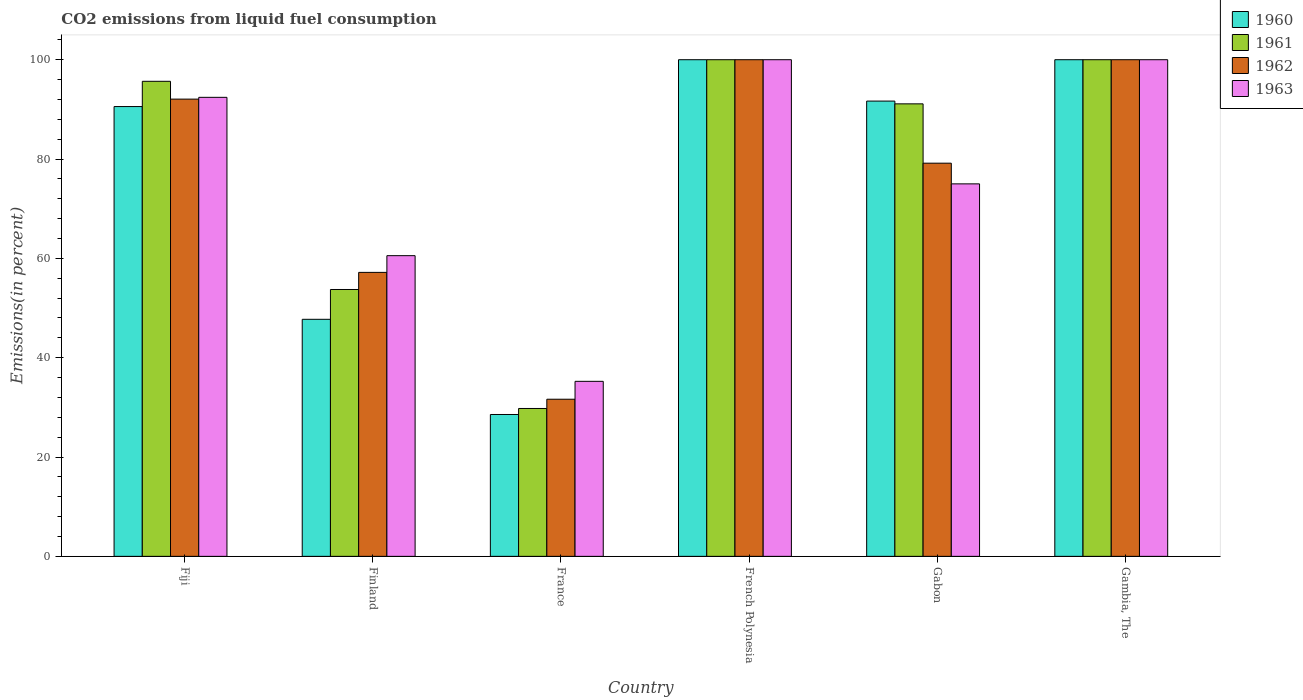How many different coloured bars are there?
Offer a terse response. 4. Are the number of bars per tick equal to the number of legend labels?
Ensure brevity in your answer.  Yes. Are the number of bars on each tick of the X-axis equal?
Provide a succinct answer. Yes. How many bars are there on the 3rd tick from the left?
Provide a short and direct response. 4. How many bars are there on the 4th tick from the right?
Offer a terse response. 4. Across all countries, what is the minimum total CO2 emitted in 1962?
Provide a short and direct response. 31.64. In which country was the total CO2 emitted in 1962 maximum?
Offer a very short reply. French Polynesia. What is the total total CO2 emitted in 1961 in the graph?
Offer a very short reply. 470.27. What is the difference between the total CO2 emitted in 1963 in Fiji and that in Gambia, The?
Your answer should be very brief. -7.58. What is the difference between the total CO2 emitted in 1961 in Gabon and the total CO2 emitted in 1963 in Finland?
Keep it short and to the point. 30.57. What is the average total CO2 emitted in 1961 per country?
Ensure brevity in your answer.  78.38. What is the difference between the total CO2 emitted of/in 1963 and total CO2 emitted of/in 1962 in France?
Your response must be concise. 3.6. In how many countries, is the total CO2 emitted in 1960 greater than 72 %?
Offer a terse response. 4. What is the ratio of the total CO2 emitted in 1961 in France to that in Gambia, The?
Your answer should be compact. 0.3. Is the total CO2 emitted in 1960 in France less than that in French Polynesia?
Your response must be concise. Yes. Is the difference between the total CO2 emitted in 1963 in Fiji and French Polynesia greater than the difference between the total CO2 emitted in 1962 in Fiji and French Polynesia?
Provide a short and direct response. Yes. What is the difference between the highest and the second highest total CO2 emitted in 1961?
Your answer should be very brief. 4.35. What is the difference between the highest and the lowest total CO2 emitted in 1962?
Make the answer very short. 68.36. What does the 3rd bar from the left in Finland represents?
Give a very brief answer. 1962. Is it the case that in every country, the sum of the total CO2 emitted in 1960 and total CO2 emitted in 1963 is greater than the total CO2 emitted in 1962?
Make the answer very short. Yes. How many bars are there?
Provide a succinct answer. 24. How many countries are there in the graph?
Provide a succinct answer. 6. What is the difference between two consecutive major ticks on the Y-axis?
Your answer should be very brief. 20. Are the values on the major ticks of Y-axis written in scientific E-notation?
Offer a terse response. No. Does the graph contain any zero values?
Offer a terse response. No. How many legend labels are there?
Keep it short and to the point. 4. What is the title of the graph?
Offer a terse response. CO2 emissions from liquid fuel consumption. Does "1977" appear as one of the legend labels in the graph?
Provide a succinct answer. No. What is the label or title of the X-axis?
Ensure brevity in your answer.  Country. What is the label or title of the Y-axis?
Your answer should be very brief. Emissions(in percent). What is the Emissions(in percent) in 1960 in Fiji?
Your response must be concise. 90.57. What is the Emissions(in percent) in 1961 in Fiji?
Ensure brevity in your answer.  95.65. What is the Emissions(in percent) of 1962 in Fiji?
Provide a short and direct response. 92.06. What is the Emissions(in percent) of 1963 in Fiji?
Your answer should be compact. 92.42. What is the Emissions(in percent) of 1960 in Finland?
Ensure brevity in your answer.  47.73. What is the Emissions(in percent) of 1961 in Finland?
Your answer should be compact. 53.73. What is the Emissions(in percent) of 1962 in Finland?
Provide a short and direct response. 57.18. What is the Emissions(in percent) in 1963 in Finland?
Give a very brief answer. 60.54. What is the Emissions(in percent) in 1960 in France?
Provide a succinct answer. 28.56. What is the Emissions(in percent) of 1961 in France?
Your response must be concise. 29.77. What is the Emissions(in percent) of 1962 in France?
Your response must be concise. 31.64. What is the Emissions(in percent) of 1963 in France?
Your answer should be very brief. 35.24. What is the Emissions(in percent) of 1961 in French Polynesia?
Offer a very short reply. 100. What is the Emissions(in percent) in 1963 in French Polynesia?
Offer a terse response. 100. What is the Emissions(in percent) of 1960 in Gabon?
Your answer should be compact. 91.67. What is the Emissions(in percent) of 1961 in Gabon?
Keep it short and to the point. 91.11. What is the Emissions(in percent) in 1962 in Gabon?
Give a very brief answer. 79.17. What is the Emissions(in percent) in 1960 in Gambia, The?
Your answer should be compact. 100. What is the Emissions(in percent) of 1963 in Gambia, The?
Your answer should be very brief. 100. Across all countries, what is the maximum Emissions(in percent) in 1960?
Your response must be concise. 100. Across all countries, what is the maximum Emissions(in percent) of 1963?
Your response must be concise. 100. Across all countries, what is the minimum Emissions(in percent) in 1960?
Provide a short and direct response. 28.56. Across all countries, what is the minimum Emissions(in percent) in 1961?
Your response must be concise. 29.77. Across all countries, what is the minimum Emissions(in percent) in 1962?
Provide a succinct answer. 31.64. Across all countries, what is the minimum Emissions(in percent) in 1963?
Offer a very short reply. 35.24. What is the total Emissions(in percent) in 1960 in the graph?
Keep it short and to the point. 458.53. What is the total Emissions(in percent) in 1961 in the graph?
Provide a succinct answer. 470.27. What is the total Emissions(in percent) of 1962 in the graph?
Your answer should be compact. 460.04. What is the total Emissions(in percent) in 1963 in the graph?
Ensure brevity in your answer.  463.21. What is the difference between the Emissions(in percent) of 1960 in Fiji and that in Finland?
Ensure brevity in your answer.  42.84. What is the difference between the Emissions(in percent) of 1961 in Fiji and that in Finland?
Your response must be concise. 41.92. What is the difference between the Emissions(in percent) of 1962 in Fiji and that in Finland?
Your answer should be compact. 34.89. What is the difference between the Emissions(in percent) of 1963 in Fiji and that in Finland?
Provide a succinct answer. 31.88. What is the difference between the Emissions(in percent) in 1960 in Fiji and that in France?
Give a very brief answer. 62. What is the difference between the Emissions(in percent) in 1961 in Fiji and that in France?
Your answer should be compact. 65.88. What is the difference between the Emissions(in percent) of 1962 in Fiji and that in France?
Provide a succinct answer. 60.43. What is the difference between the Emissions(in percent) in 1963 in Fiji and that in France?
Offer a very short reply. 57.18. What is the difference between the Emissions(in percent) of 1960 in Fiji and that in French Polynesia?
Your answer should be very brief. -9.43. What is the difference between the Emissions(in percent) of 1961 in Fiji and that in French Polynesia?
Give a very brief answer. -4.35. What is the difference between the Emissions(in percent) in 1962 in Fiji and that in French Polynesia?
Keep it short and to the point. -7.94. What is the difference between the Emissions(in percent) of 1963 in Fiji and that in French Polynesia?
Your answer should be compact. -7.58. What is the difference between the Emissions(in percent) in 1960 in Fiji and that in Gabon?
Keep it short and to the point. -1.1. What is the difference between the Emissions(in percent) in 1961 in Fiji and that in Gabon?
Offer a terse response. 4.54. What is the difference between the Emissions(in percent) of 1962 in Fiji and that in Gabon?
Your answer should be compact. 12.9. What is the difference between the Emissions(in percent) in 1963 in Fiji and that in Gabon?
Keep it short and to the point. 17.42. What is the difference between the Emissions(in percent) in 1960 in Fiji and that in Gambia, The?
Keep it short and to the point. -9.43. What is the difference between the Emissions(in percent) in 1961 in Fiji and that in Gambia, The?
Provide a succinct answer. -4.35. What is the difference between the Emissions(in percent) in 1962 in Fiji and that in Gambia, The?
Your answer should be compact. -7.94. What is the difference between the Emissions(in percent) in 1963 in Fiji and that in Gambia, The?
Keep it short and to the point. -7.58. What is the difference between the Emissions(in percent) in 1960 in Finland and that in France?
Ensure brevity in your answer.  19.17. What is the difference between the Emissions(in percent) of 1961 in Finland and that in France?
Your answer should be very brief. 23.96. What is the difference between the Emissions(in percent) in 1962 in Finland and that in France?
Provide a succinct answer. 25.54. What is the difference between the Emissions(in percent) of 1963 in Finland and that in France?
Ensure brevity in your answer.  25.3. What is the difference between the Emissions(in percent) of 1960 in Finland and that in French Polynesia?
Provide a short and direct response. -52.27. What is the difference between the Emissions(in percent) in 1961 in Finland and that in French Polynesia?
Ensure brevity in your answer.  -46.27. What is the difference between the Emissions(in percent) of 1962 in Finland and that in French Polynesia?
Give a very brief answer. -42.82. What is the difference between the Emissions(in percent) of 1963 in Finland and that in French Polynesia?
Your response must be concise. -39.46. What is the difference between the Emissions(in percent) of 1960 in Finland and that in Gabon?
Give a very brief answer. -43.94. What is the difference between the Emissions(in percent) in 1961 in Finland and that in Gabon?
Ensure brevity in your answer.  -37.38. What is the difference between the Emissions(in percent) of 1962 in Finland and that in Gabon?
Offer a very short reply. -21.99. What is the difference between the Emissions(in percent) in 1963 in Finland and that in Gabon?
Provide a short and direct response. -14.46. What is the difference between the Emissions(in percent) of 1960 in Finland and that in Gambia, The?
Ensure brevity in your answer.  -52.27. What is the difference between the Emissions(in percent) of 1961 in Finland and that in Gambia, The?
Ensure brevity in your answer.  -46.27. What is the difference between the Emissions(in percent) of 1962 in Finland and that in Gambia, The?
Your answer should be very brief. -42.82. What is the difference between the Emissions(in percent) in 1963 in Finland and that in Gambia, The?
Offer a very short reply. -39.46. What is the difference between the Emissions(in percent) in 1960 in France and that in French Polynesia?
Provide a succinct answer. -71.44. What is the difference between the Emissions(in percent) of 1961 in France and that in French Polynesia?
Make the answer very short. -70.23. What is the difference between the Emissions(in percent) of 1962 in France and that in French Polynesia?
Make the answer very short. -68.36. What is the difference between the Emissions(in percent) of 1963 in France and that in French Polynesia?
Your answer should be compact. -64.76. What is the difference between the Emissions(in percent) of 1960 in France and that in Gabon?
Offer a terse response. -63.1. What is the difference between the Emissions(in percent) in 1961 in France and that in Gabon?
Ensure brevity in your answer.  -61.34. What is the difference between the Emissions(in percent) of 1962 in France and that in Gabon?
Your response must be concise. -47.53. What is the difference between the Emissions(in percent) in 1963 in France and that in Gabon?
Ensure brevity in your answer.  -39.76. What is the difference between the Emissions(in percent) of 1960 in France and that in Gambia, The?
Provide a succinct answer. -71.44. What is the difference between the Emissions(in percent) of 1961 in France and that in Gambia, The?
Offer a very short reply. -70.23. What is the difference between the Emissions(in percent) in 1962 in France and that in Gambia, The?
Your answer should be very brief. -68.36. What is the difference between the Emissions(in percent) of 1963 in France and that in Gambia, The?
Keep it short and to the point. -64.76. What is the difference between the Emissions(in percent) of 1960 in French Polynesia and that in Gabon?
Your response must be concise. 8.33. What is the difference between the Emissions(in percent) of 1961 in French Polynesia and that in Gabon?
Your answer should be compact. 8.89. What is the difference between the Emissions(in percent) of 1962 in French Polynesia and that in Gabon?
Offer a very short reply. 20.83. What is the difference between the Emissions(in percent) of 1962 in French Polynesia and that in Gambia, The?
Provide a succinct answer. 0. What is the difference between the Emissions(in percent) of 1960 in Gabon and that in Gambia, The?
Your response must be concise. -8.33. What is the difference between the Emissions(in percent) of 1961 in Gabon and that in Gambia, The?
Offer a terse response. -8.89. What is the difference between the Emissions(in percent) of 1962 in Gabon and that in Gambia, The?
Make the answer very short. -20.83. What is the difference between the Emissions(in percent) of 1960 in Fiji and the Emissions(in percent) of 1961 in Finland?
Provide a short and direct response. 36.84. What is the difference between the Emissions(in percent) of 1960 in Fiji and the Emissions(in percent) of 1962 in Finland?
Provide a succinct answer. 33.39. What is the difference between the Emissions(in percent) in 1960 in Fiji and the Emissions(in percent) in 1963 in Finland?
Offer a very short reply. 30.02. What is the difference between the Emissions(in percent) of 1961 in Fiji and the Emissions(in percent) of 1962 in Finland?
Ensure brevity in your answer.  38.48. What is the difference between the Emissions(in percent) in 1961 in Fiji and the Emissions(in percent) in 1963 in Finland?
Make the answer very short. 35.11. What is the difference between the Emissions(in percent) in 1962 in Fiji and the Emissions(in percent) in 1963 in Finland?
Your response must be concise. 31.52. What is the difference between the Emissions(in percent) of 1960 in Fiji and the Emissions(in percent) of 1961 in France?
Your response must be concise. 60.79. What is the difference between the Emissions(in percent) in 1960 in Fiji and the Emissions(in percent) in 1962 in France?
Provide a short and direct response. 58.93. What is the difference between the Emissions(in percent) in 1960 in Fiji and the Emissions(in percent) in 1963 in France?
Offer a terse response. 55.33. What is the difference between the Emissions(in percent) in 1961 in Fiji and the Emissions(in percent) in 1962 in France?
Provide a succinct answer. 64.02. What is the difference between the Emissions(in percent) of 1961 in Fiji and the Emissions(in percent) of 1963 in France?
Offer a very short reply. 60.41. What is the difference between the Emissions(in percent) of 1962 in Fiji and the Emissions(in percent) of 1963 in France?
Your answer should be compact. 56.82. What is the difference between the Emissions(in percent) in 1960 in Fiji and the Emissions(in percent) in 1961 in French Polynesia?
Offer a very short reply. -9.43. What is the difference between the Emissions(in percent) in 1960 in Fiji and the Emissions(in percent) in 1962 in French Polynesia?
Provide a succinct answer. -9.43. What is the difference between the Emissions(in percent) in 1960 in Fiji and the Emissions(in percent) in 1963 in French Polynesia?
Keep it short and to the point. -9.43. What is the difference between the Emissions(in percent) in 1961 in Fiji and the Emissions(in percent) in 1962 in French Polynesia?
Provide a short and direct response. -4.35. What is the difference between the Emissions(in percent) in 1961 in Fiji and the Emissions(in percent) in 1963 in French Polynesia?
Offer a very short reply. -4.35. What is the difference between the Emissions(in percent) in 1962 in Fiji and the Emissions(in percent) in 1963 in French Polynesia?
Provide a succinct answer. -7.94. What is the difference between the Emissions(in percent) of 1960 in Fiji and the Emissions(in percent) of 1961 in Gabon?
Make the answer very short. -0.55. What is the difference between the Emissions(in percent) in 1960 in Fiji and the Emissions(in percent) in 1962 in Gabon?
Provide a short and direct response. 11.4. What is the difference between the Emissions(in percent) in 1960 in Fiji and the Emissions(in percent) in 1963 in Gabon?
Provide a short and direct response. 15.57. What is the difference between the Emissions(in percent) of 1961 in Fiji and the Emissions(in percent) of 1962 in Gabon?
Your answer should be compact. 16.49. What is the difference between the Emissions(in percent) in 1961 in Fiji and the Emissions(in percent) in 1963 in Gabon?
Make the answer very short. 20.65. What is the difference between the Emissions(in percent) of 1962 in Fiji and the Emissions(in percent) of 1963 in Gabon?
Offer a terse response. 17.06. What is the difference between the Emissions(in percent) in 1960 in Fiji and the Emissions(in percent) in 1961 in Gambia, The?
Give a very brief answer. -9.43. What is the difference between the Emissions(in percent) of 1960 in Fiji and the Emissions(in percent) of 1962 in Gambia, The?
Offer a terse response. -9.43. What is the difference between the Emissions(in percent) of 1960 in Fiji and the Emissions(in percent) of 1963 in Gambia, The?
Your answer should be compact. -9.43. What is the difference between the Emissions(in percent) in 1961 in Fiji and the Emissions(in percent) in 1962 in Gambia, The?
Ensure brevity in your answer.  -4.35. What is the difference between the Emissions(in percent) in 1961 in Fiji and the Emissions(in percent) in 1963 in Gambia, The?
Keep it short and to the point. -4.35. What is the difference between the Emissions(in percent) of 1962 in Fiji and the Emissions(in percent) of 1963 in Gambia, The?
Your answer should be compact. -7.94. What is the difference between the Emissions(in percent) of 1960 in Finland and the Emissions(in percent) of 1961 in France?
Your answer should be very brief. 17.96. What is the difference between the Emissions(in percent) in 1960 in Finland and the Emissions(in percent) in 1962 in France?
Give a very brief answer. 16.09. What is the difference between the Emissions(in percent) in 1960 in Finland and the Emissions(in percent) in 1963 in France?
Make the answer very short. 12.49. What is the difference between the Emissions(in percent) of 1961 in Finland and the Emissions(in percent) of 1962 in France?
Make the answer very short. 22.09. What is the difference between the Emissions(in percent) of 1961 in Finland and the Emissions(in percent) of 1963 in France?
Provide a succinct answer. 18.49. What is the difference between the Emissions(in percent) in 1962 in Finland and the Emissions(in percent) in 1963 in France?
Provide a short and direct response. 21.94. What is the difference between the Emissions(in percent) of 1960 in Finland and the Emissions(in percent) of 1961 in French Polynesia?
Make the answer very short. -52.27. What is the difference between the Emissions(in percent) of 1960 in Finland and the Emissions(in percent) of 1962 in French Polynesia?
Provide a short and direct response. -52.27. What is the difference between the Emissions(in percent) in 1960 in Finland and the Emissions(in percent) in 1963 in French Polynesia?
Ensure brevity in your answer.  -52.27. What is the difference between the Emissions(in percent) in 1961 in Finland and the Emissions(in percent) in 1962 in French Polynesia?
Offer a very short reply. -46.27. What is the difference between the Emissions(in percent) in 1961 in Finland and the Emissions(in percent) in 1963 in French Polynesia?
Make the answer very short. -46.27. What is the difference between the Emissions(in percent) of 1962 in Finland and the Emissions(in percent) of 1963 in French Polynesia?
Provide a short and direct response. -42.82. What is the difference between the Emissions(in percent) of 1960 in Finland and the Emissions(in percent) of 1961 in Gabon?
Offer a very short reply. -43.38. What is the difference between the Emissions(in percent) in 1960 in Finland and the Emissions(in percent) in 1962 in Gabon?
Give a very brief answer. -31.44. What is the difference between the Emissions(in percent) of 1960 in Finland and the Emissions(in percent) of 1963 in Gabon?
Your response must be concise. -27.27. What is the difference between the Emissions(in percent) in 1961 in Finland and the Emissions(in percent) in 1962 in Gabon?
Your answer should be very brief. -25.44. What is the difference between the Emissions(in percent) of 1961 in Finland and the Emissions(in percent) of 1963 in Gabon?
Offer a very short reply. -21.27. What is the difference between the Emissions(in percent) of 1962 in Finland and the Emissions(in percent) of 1963 in Gabon?
Ensure brevity in your answer.  -17.82. What is the difference between the Emissions(in percent) in 1960 in Finland and the Emissions(in percent) in 1961 in Gambia, The?
Your response must be concise. -52.27. What is the difference between the Emissions(in percent) in 1960 in Finland and the Emissions(in percent) in 1962 in Gambia, The?
Your answer should be very brief. -52.27. What is the difference between the Emissions(in percent) of 1960 in Finland and the Emissions(in percent) of 1963 in Gambia, The?
Offer a terse response. -52.27. What is the difference between the Emissions(in percent) of 1961 in Finland and the Emissions(in percent) of 1962 in Gambia, The?
Your answer should be compact. -46.27. What is the difference between the Emissions(in percent) of 1961 in Finland and the Emissions(in percent) of 1963 in Gambia, The?
Keep it short and to the point. -46.27. What is the difference between the Emissions(in percent) in 1962 in Finland and the Emissions(in percent) in 1963 in Gambia, The?
Provide a short and direct response. -42.82. What is the difference between the Emissions(in percent) in 1960 in France and the Emissions(in percent) in 1961 in French Polynesia?
Provide a short and direct response. -71.44. What is the difference between the Emissions(in percent) of 1960 in France and the Emissions(in percent) of 1962 in French Polynesia?
Provide a short and direct response. -71.44. What is the difference between the Emissions(in percent) in 1960 in France and the Emissions(in percent) in 1963 in French Polynesia?
Offer a very short reply. -71.44. What is the difference between the Emissions(in percent) in 1961 in France and the Emissions(in percent) in 1962 in French Polynesia?
Your answer should be very brief. -70.23. What is the difference between the Emissions(in percent) of 1961 in France and the Emissions(in percent) of 1963 in French Polynesia?
Provide a succinct answer. -70.23. What is the difference between the Emissions(in percent) in 1962 in France and the Emissions(in percent) in 1963 in French Polynesia?
Ensure brevity in your answer.  -68.36. What is the difference between the Emissions(in percent) of 1960 in France and the Emissions(in percent) of 1961 in Gabon?
Provide a succinct answer. -62.55. What is the difference between the Emissions(in percent) of 1960 in France and the Emissions(in percent) of 1962 in Gabon?
Offer a very short reply. -50.6. What is the difference between the Emissions(in percent) of 1960 in France and the Emissions(in percent) of 1963 in Gabon?
Your response must be concise. -46.44. What is the difference between the Emissions(in percent) in 1961 in France and the Emissions(in percent) in 1962 in Gabon?
Your answer should be very brief. -49.39. What is the difference between the Emissions(in percent) in 1961 in France and the Emissions(in percent) in 1963 in Gabon?
Offer a terse response. -45.23. What is the difference between the Emissions(in percent) of 1962 in France and the Emissions(in percent) of 1963 in Gabon?
Your answer should be compact. -43.36. What is the difference between the Emissions(in percent) in 1960 in France and the Emissions(in percent) in 1961 in Gambia, The?
Provide a succinct answer. -71.44. What is the difference between the Emissions(in percent) of 1960 in France and the Emissions(in percent) of 1962 in Gambia, The?
Offer a very short reply. -71.44. What is the difference between the Emissions(in percent) of 1960 in France and the Emissions(in percent) of 1963 in Gambia, The?
Ensure brevity in your answer.  -71.44. What is the difference between the Emissions(in percent) in 1961 in France and the Emissions(in percent) in 1962 in Gambia, The?
Provide a succinct answer. -70.23. What is the difference between the Emissions(in percent) in 1961 in France and the Emissions(in percent) in 1963 in Gambia, The?
Your response must be concise. -70.23. What is the difference between the Emissions(in percent) of 1962 in France and the Emissions(in percent) of 1963 in Gambia, The?
Provide a short and direct response. -68.36. What is the difference between the Emissions(in percent) of 1960 in French Polynesia and the Emissions(in percent) of 1961 in Gabon?
Offer a terse response. 8.89. What is the difference between the Emissions(in percent) of 1960 in French Polynesia and the Emissions(in percent) of 1962 in Gabon?
Provide a succinct answer. 20.83. What is the difference between the Emissions(in percent) of 1960 in French Polynesia and the Emissions(in percent) of 1963 in Gabon?
Provide a short and direct response. 25. What is the difference between the Emissions(in percent) in 1961 in French Polynesia and the Emissions(in percent) in 1962 in Gabon?
Keep it short and to the point. 20.83. What is the difference between the Emissions(in percent) of 1961 in French Polynesia and the Emissions(in percent) of 1963 in Gabon?
Your response must be concise. 25. What is the difference between the Emissions(in percent) in 1962 in French Polynesia and the Emissions(in percent) in 1963 in Gabon?
Provide a succinct answer. 25. What is the difference between the Emissions(in percent) in 1960 in French Polynesia and the Emissions(in percent) in 1961 in Gambia, The?
Your answer should be compact. 0. What is the difference between the Emissions(in percent) of 1960 in French Polynesia and the Emissions(in percent) of 1962 in Gambia, The?
Make the answer very short. 0. What is the difference between the Emissions(in percent) in 1960 in French Polynesia and the Emissions(in percent) in 1963 in Gambia, The?
Provide a succinct answer. 0. What is the difference between the Emissions(in percent) in 1961 in French Polynesia and the Emissions(in percent) in 1963 in Gambia, The?
Your response must be concise. 0. What is the difference between the Emissions(in percent) in 1962 in French Polynesia and the Emissions(in percent) in 1963 in Gambia, The?
Your answer should be compact. 0. What is the difference between the Emissions(in percent) of 1960 in Gabon and the Emissions(in percent) of 1961 in Gambia, The?
Give a very brief answer. -8.33. What is the difference between the Emissions(in percent) in 1960 in Gabon and the Emissions(in percent) in 1962 in Gambia, The?
Ensure brevity in your answer.  -8.33. What is the difference between the Emissions(in percent) of 1960 in Gabon and the Emissions(in percent) of 1963 in Gambia, The?
Offer a very short reply. -8.33. What is the difference between the Emissions(in percent) in 1961 in Gabon and the Emissions(in percent) in 1962 in Gambia, The?
Your answer should be very brief. -8.89. What is the difference between the Emissions(in percent) of 1961 in Gabon and the Emissions(in percent) of 1963 in Gambia, The?
Give a very brief answer. -8.89. What is the difference between the Emissions(in percent) in 1962 in Gabon and the Emissions(in percent) in 1963 in Gambia, The?
Provide a succinct answer. -20.83. What is the average Emissions(in percent) of 1960 per country?
Your answer should be compact. 76.42. What is the average Emissions(in percent) in 1961 per country?
Your answer should be compact. 78.38. What is the average Emissions(in percent) of 1962 per country?
Your answer should be very brief. 76.67. What is the average Emissions(in percent) of 1963 per country?
Your answer should be very brief. 77.2. What is the difference between the Emissions(in percent) of 1960 and Emissions(in percent) of 1961 in Fiji?
Keep it short and to the point. -5.09. What is the difference between the Emissions(in percent) of 1960 and Emissions(in percent) of 1962 in Fiji?
Make the answer very short. -1.5. What is the difference between the Emissions(in percent) in 1960 and Emissions(in percent) in 1963 in Fiji?
Offer a terse response. -1.86. What is the difference between the Emissions(in percent) of 1961 and Emissions(in percent) of 1962 in Fiji?
Offer a very short reply. 3.59. What is the difference between the Emissions(in percent) of 1961 and Emissions(in percent) of 1963 in Fiji?
Provide a short and direct response. 3.23. What is the difference between the Emissions(in percent) in 1962 and Emissions(in percent) in 1963 in Fiji?
Offer a terse response. -0.36. What is the difference between the Emissions(in percent) in 1960 and Emissions(in percent) in 1961 in Finland?
Keep it short and to the point. -6. What is the difference between the Emissions(in percent) of 1960 and Emissions(in percent) of 1962 in Finland?
Offer a very short reply. -9.45. What is the difference between the Emissions(in percent) of 1960 and Emissions(in percent) of 1963 in Finland?
Offer a terse response. -12.81. What is the difference between the Emissions(in percent) in 1961 and Emissions(in percent) in 1962 in Finland?
Your response must be concise. -3.45. What is the difference between the Emissions(in percent) of 1961 and Emissions(in percent) of 1963 in Finland?
Ensure brevity in your answer.  -6.81. What is the difference between the Emissions(in percent) of 1962 and Emissions(in percent) of 1963 in Finland?
Your response must be concise. -3.36. What is the difference between the Emissions(in percent) in 1960 and Emissions(in percent) in 1961 in France?
Give a very brief answer. -1.21. What is the difference between the Emissions(in percent) of 1960 and Emissions(in percent) of 1962 in France?
Provide a short and direct response. -3.07. What is the difference between the Emissions(in percent) in 1960 and Emissions(in percent) in 1963 in France?
Offer a terse response. -6.68. What is the difference between the Emissions(in percent) of 1961 and Emissions(in percent) of 1962 in France?
Make the answer very short. -1.86. What is the difference between the Emissions(in percent) in 1961 and Emissions(in percent) in 1963 in France?
Your answer should be very brief. -5.47. What is the difference between the Emissions(in percent) of 1962 and Emissions(in percent) of 1963 in France?
Keep it short and to the point. -3.6. What is the difference between the Emissions(in percent) of 1962 and Emissions(in percent) of 1963 in French Polynesia?
Make the answer very short. 0. What is the difference between the Emissions(in percent) of 1960 and Emissions(in percent) of 1961 in Gabon?
Provide a succinct answer. 0.56. What is the difference between the Emissions(in percent) in 1960 and Emissions(in percent) in 1962 in Gabon?
Provide a short and direct response. 12.5. What is the difference between the Emissions(in percent) in 1960 and Emissions(in percent) in 1963 in Gabon?
Your answer should be very brief. 16.67. What is the difference between the Emissions(in percent) in 1961 and Emissions(in percent) in 1962 in Gabon?
Your response must be concise. 11.94. What is the difference between the Emissions(in percent) of 1961 and Emissions(in percent) of 1963 in Gabon?
Your response must be concise. 16.11. What is the difference between the Emissions(in percent) in 1962 and Emissions(in percent) in 1963 in Gabon?
Offer a terse response. 4.17. What is the difference between the Emissions(in percent) in 1960 and Emissions(in percent) in 1961 in Gambia, The?
Make the answer very short. 0. What is the difference between the Emissions(in percent) of 1960 and Emissions(in percent) of 1963 in Gambia, The?
Offer a very short reply. 0. What is the difference between the Emissions(in percent) of 1961 and Emissions(in percent) of 1963 in Gambia, The?
Your answer should be compact. 0. What is the ratio of the Emissions(in percent) of 1960 in Fiji to that in Finland?
Make the answer very short. 1.9. What is the ratio of the Emissions(in percent) of 1961 in Fiji to that in Finland?
Offer a terse response. 1.78. What is the ratio of the Emissions(in percent) of 1962 in Fiji to that in Finland?
Offer a terse response. 1.61. What is the ratio of the Emissions(in percent) in 1963 in Fiji to that in Finland?
Keep it short and to the point. 1.53. What is the ratio of the Emissions(in percent) in 1960 in Fiji to that in France?
Offer a terse response. 3.17. What is the ratio of the Emissions(in percent) of 1961 in Fiji to that in France?
Offer a terse response. 3.21. What is the ratio of the Emissions(in percent) in 1962 in Fiji to that in France?
Offer a terse response. 2.91. What is the ratio of the Emissions(in percent) of 1963 in Fiji to that in France?
Offer a very short reply. 2.62. What is the ratio of the Emissions(in percent) in 1960 in Fiji to that in French Polynesia?
Provide a succinct answer. 0.91. What is the ratio of the Emissions(in percent) of 1961 in Fiji to that in French Polynesia?
Give a very brief answer. 0.96. What is the ratio of the Emissions(in percent) of 1962 in Fiji to that in French Polynesia?
Ensure brevity in your answer.  0.92. What is the ratio of the Emissions(in percent) of 1963 in Fiji to that in French Polynesia?
Offer a terse response. 0.92. What is the ratio of the Emissions(in percent) of 1960 in Fiji to that in Gabon?
Your answer should be very brief. 0.99. What is the ratio of the Emissions(in percent) of 1961 in Fiji to that in Gabon?
Make the answer very short. 1.05. What is the ratio of the Emissions(in percent) of 1962 in Fiji to that in Gabon?
Your answer should be compact. 1.16. What is the ratio of the Emissions(in percent) in 1963 in Fiji to that in Gabon?
Keep it short and to the point. 1.23. What is the ratio of the Emissions(in percent) of 1960 in Fiji to that in Gambia, The?
Your answer should be very brief. 0.91. What is the ratio of the Emissions(in percent) of 1961 in Fiji to that in Gambia, The?
Your answer should be very brief. 0.96. What is the ratio of the Emissions(in percent) of 1962 in Fiji to that in Gambia, The?
Keep it short and to the point. 0.92. What is the ratio of the Emissions(in percent) in 1963 in Fiji to that in Gambia, The?
Provide a short and direct response. 0.92. What is the ratio of the Emissions(in percent) in 1960 in Finland to that in France?
Ensure brevity in your answer.  1.67. What is the ratio of the Emissions(in percent) in 1961 in Finland to that in France?
Provide a short and direct response. 1.8. What is the ratio of the Emissions(in percent) in 1962 in Finland to that in France?
Provide a succinct answer. 1.81. What is the ratio of the Emissions(in percent) in 1963 in Finland to that in France?
Provide a succinct answer. 1.72. What is the ratio of the Emissions(in percent) of 1960 in Finland to that in French Polynesia?
Provide a short and direct response. 0.48. What is the ratio of the Emissions(in percent) in 1961 in Finland to that in French Polynesia?
Make the answer very short. 0.54. What is the ratio of the Emissions(in percent) of 1962 in Finland to that in French Polynesia?
Your response must be concise. 0.57. What is the ratio of the Emissions(in percent) in 1963 in Finland to that in French Polynesia?
Ensure brevity in your answer.  0.61. What is the ratio of the Emissions(in percent) of 1960 in Finland to that in Gabon?
Offer a very short reply. 0.52. What is the ratio of the Emissions(in percent) in 1961 in Finland to that in Gabon?
Offer a terse response. 0.59. What is the ratio of the Emissions(in percent) in 1962 in Finland to that in Gabon?
Provide a short and direct response. 0.72. What is the ratio of the Emissions(in percent) of 1963 in Finland to that in Gabon?
Your response must be concise. 0.81. What is the ratio of the Emissions(in percent) in 1960 in Finland to that in Gambia, The?
Make the answer very short. 0.48. What is the ratio of the Emissions(in percent) of 1961 in Finland to that in Gambia, The?
Provide a short and direct response. 0.54. What is the ratio of the Emissions(in percent) of 1962 in Finland to that in Gambia, The?
Your answer should be very brief. 0.57. What is the ratio of the Emissions(in percent) of 1963 in Finland to that in Gambia, The?
Offer a terse response. 0.61. What is the ratio of the Emissions(in percent) in 1960 in France to that in French Polynesia?
Your response must be concise. 0.29. What is the ratio of the Emissions(in percent) in 1961 in France to that in French Polynesia?
Provide a succinct answer. 0.3. What is the ratio of the Emissions(in percent) of 1962 in France to that in French Polynesia?
Keep it short and to the point. 0.32. What is the ratio of the Emissions(in percent) in 1963 in France to that in French Polynesia?
Make the answer very short. 0.35. What is the ratio of the Emissions(in percent) in 1960 in France to that in Gabon?
Your response must be concise. 0.31. What is the ratio of the Emissions(in percent) in 1961 in France to that in Gabon?
Keep it short and to the point. 0.33. What is the ratio of the Emissions(in percent) in 1962 in France to that in Gabon?
Offer a very short reply. 0.4. What is the ratio of the Emissions(in percent) in 1963 in France to that in Gabon?
Offer a very short reply. 0.47. What is the ratio of the Emissions(in percent) of 1960 in France to that in Gambia, The?
Provide a short and direct response. 0.29. What is the ratio of the Emissions(in percent) in 1961 in France to that in Gambia, The?
Ensure brevity in your answer.  0.3. What is the ratio of the Emissions(in percent) in 1962 in France to that in Gambia, The?
Offer a terse response. 0.32. What is the ratio of the Emissions(in percent) of 1963 in France to that in Gambia, The?
Offer a terse response. 0.35. What is the ratio of the Emissions(in percent) in 1960 in French Polynesia to that in Gabon?
Keep it short and to the point. 1.09. What is the ratio of the Emissions(in percent) in 1961 in French Polynesia to that in Gabon?
Make the answer very short. 1.1. What is the ratio of the Emissions(in percent) of 1962 in French Polynesia to that in Gabon?
Provide a short and direct response. 1.26. What is the ratio of the Emissions(in percent) of 1963 in French Polynesia to that in Gabon?
Offer a very short reply. 1.33. What is the ratio of the Emissions(in percent) of 1960 in French Polynesia to that in Gambia, The?
Give a very brief answer. 1. What is the ratio of the Emissions(in percent) in 1963 in French Polynesia to that in Gambia, The?
Your response must be concise. 1. What is the ratio of the Emissions(in percent) in 1960 in Gabon to that in Gambia, The?
Give a very brief answer. 0.92. What is the ratio of the Emissions(in percent) in 1961 in Gabon to that in Gambia, The?
Your response must be concise. 0.91. What is the ratio of the Emissions(in percent) of 1962 in Gabon to that in Gambia, The?
Give a very brief answer. 0.79. What is the ratio of the Emissions(in percent) of 1963 in Gabon to that in Gambia, The?
Your answer should be very brief. 0.75. What is the difference between the highest and the second highest Emissions(in percent) in 1961?
Keep it short and to the point. 0. What is the difference between the highest and the second highest Emissions(in percent) of 1962?
Your answer should be compact. 0. What is the difference between the highest and the lowest Emissions(in percent) in 1960?
Your answer should be very brief. 71.44. What is the difference between the highest and the lowest Emissions(in percent) of 1961?
Offer a very short reply. 70.23. What is the difference between the highest and the lowest Emissions(in percent) in 1962?
Give a very brief answer. 68.36. What is the difference between the highest and the lowest Emissions(in percent) of 1963?
Your response must be concise. 64.76. 